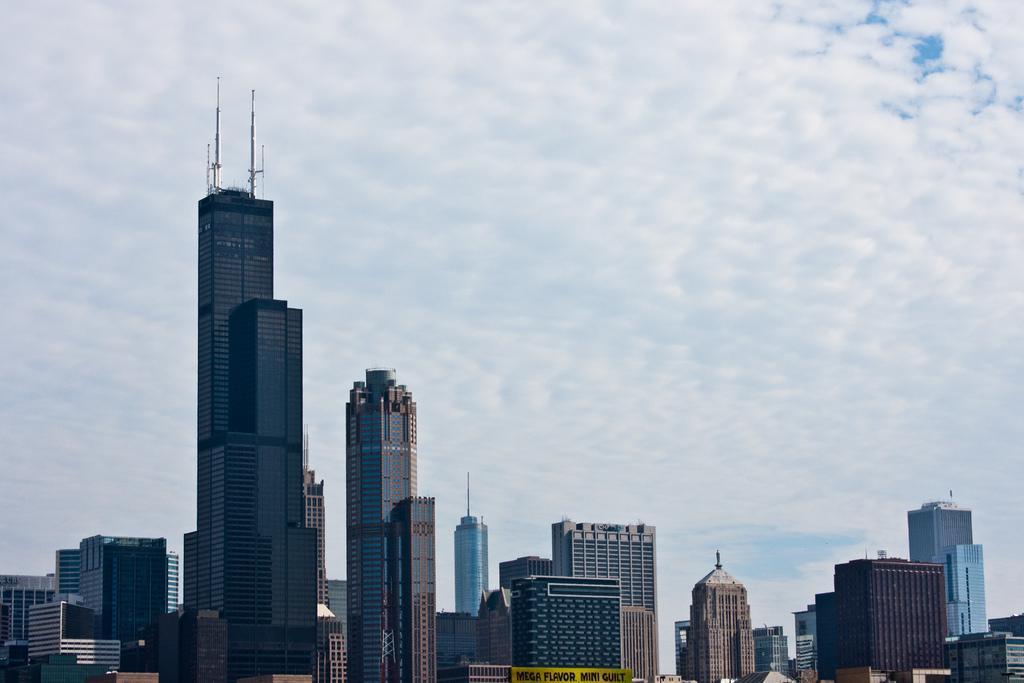Can you describe this image briefly? In this image I can see few buildings, background I can see the sky in white and blue color. 